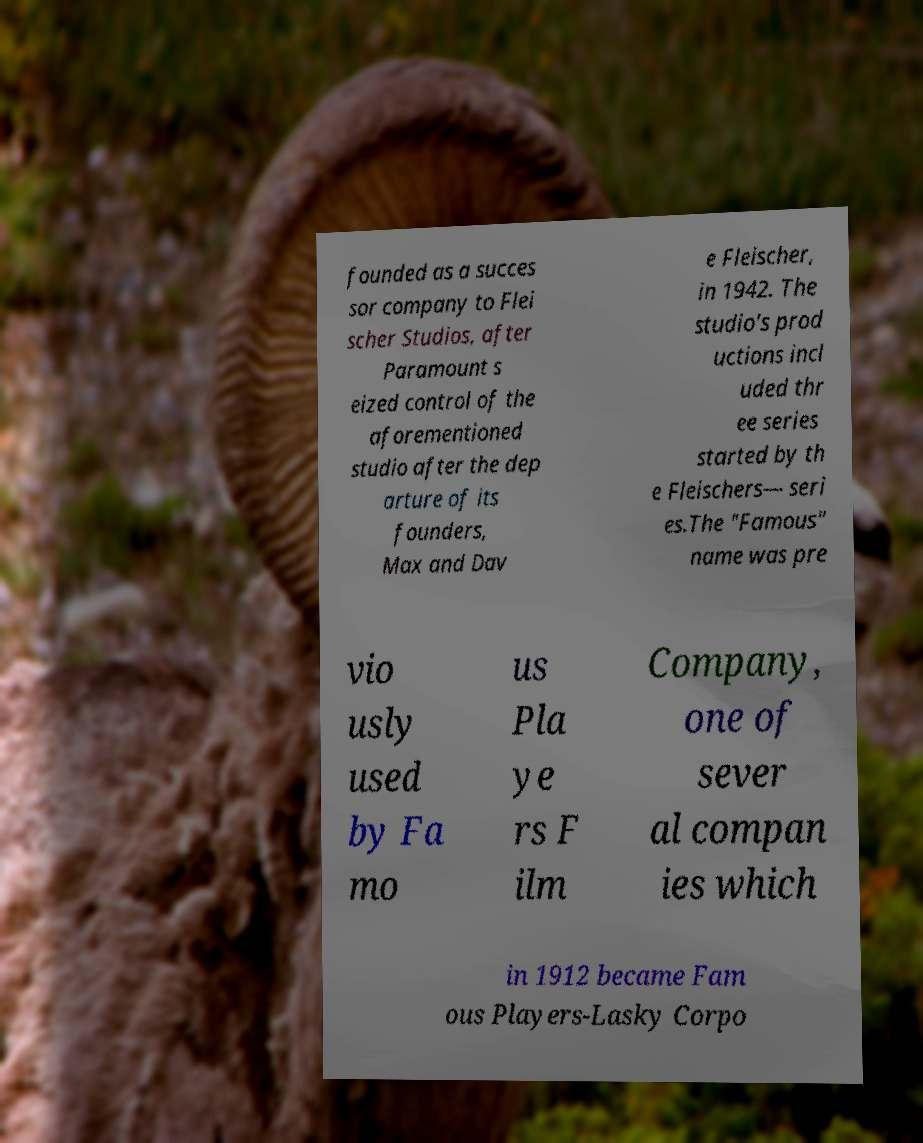Please identify and transcribe the text found in this image. founded as a succes sor company to Flei scher Studios, after Paramount s eized control of the aforementioned studio after the dep arture of its founders, Max and Dav e Fleischer, in 1942. The studio's prod uctions incl uded thr ee series started by th e Fleischers— seri es.The "Famous" name was pre vio usly used by Fa mo us Pla ye rs F ilm Company, one of sever al compan ies which in 1912 became Fam ous Players-Lasky Corpo 